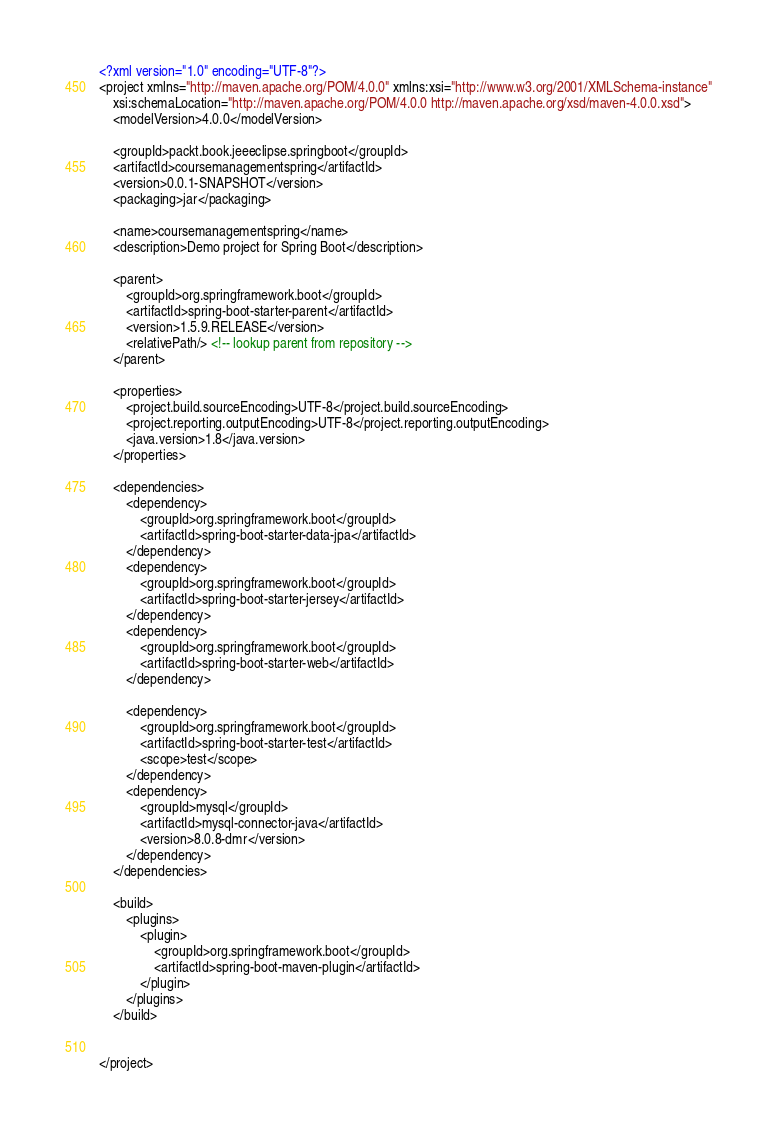<code> <loc_0><loc_0><loc_500><loc_500><_XML_><?xml version="1.0" encoding="UTF-8"?>
<project xmlns="http://maven.apache.org/POM/4.0.0" xmlns:xsi="http://www.w3.org/2001/XMLSchema-instance"
	xsi:schemaLocation="http://maven.apache.org/POM/4.0.0 http://maven.apache.org/xsd/maven-4.0.0.xsd">
	<modelVersion>4.0.0</modelVersion>

	<groupId>packt.book.jeeeclipse.springboot</groupId>
	<artifactId>coursemanagementspring</artifactId>
	<version>0.0.1-SNAPSHOT</version>
	<packaging>jar</packaging>

	<name>coursemanagementspring</name>
	<description>Demo project for Spring Boot</description>

	<parent>
		<groupId>org.springframework.boot</groupId>
		<artifactId>spring-boot-starter-parent</artifactId>
		<version>1.5.9.RELEASE</version>
		<relativePath/> <!-- lookup parent from repository -->
	</parent>

	<properties>
		<project.build.sourceEncoding>UTF-8</project.build.sourceEncoding>
		<project.reporting.outputEncoding>UTF-8</project.reporting.outputEncoding>
		<java.version>1.8</java.version>
	</properties>

	<dependencies>
		<dependency>
			<groupId>org.springframework.boot</groupId>
			<artifactId>spring-boot-starter-data-jpa</artifactId>
		</dependency>
		<dependency>
			<groupId>org.springframework.boot</groupId>
			<artifactId>spring-boot-starter-jersey</artifactId>
		</dependency>
		<dependency>
			<groupId>org.springframework.boot</groupId>
			<artifactId>spring-boot-starter-web</artifactId>
		</dependency>

		<dependency>
			<groupId>org.springframework.boot</groupId>
			<artifactId>spring-boot-starter-test</artifactId>
			<scope>test</scope>
		</dependency>
		<dependency>
			<groupId>mysql</groupId>
			<artifactId>mysql-connector-java</artifactId>
			<version>8.0.8-dmr</version>
		</dependency>
	</dependencies>

	<build>
		<plugins>
			<plugin>
				<groupId>org.springframework.boot</groupId>
				<artifactId>spring-boot-maven-plugin</artifactId>
			</plugin>
		</plugins>
	</build>


</project>
</code> 